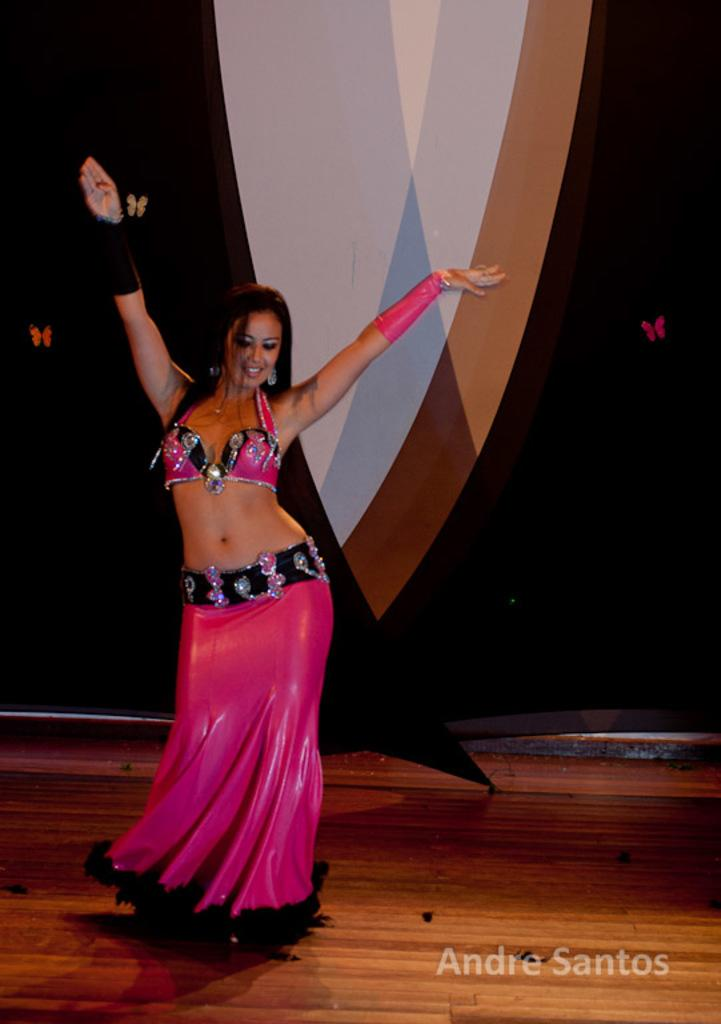Who is the main subject in the image? There is a girl in the image. What is the girl doing in the image? The girl is dancing. What type of floor is the girl dancing on? The girl is on a wooden floor. What can be seen in the background of the image? There is a curtain in the background of the image. Where is the text located in the image? The text is in the bottom right corner of the image. What type of plane can be seen flying in the background of the image? There is no plane visible in the background of the image. Is the girl cooking anything on a stove in the image? There is no stove present in the image, and the girl is dancing, not cooking. 